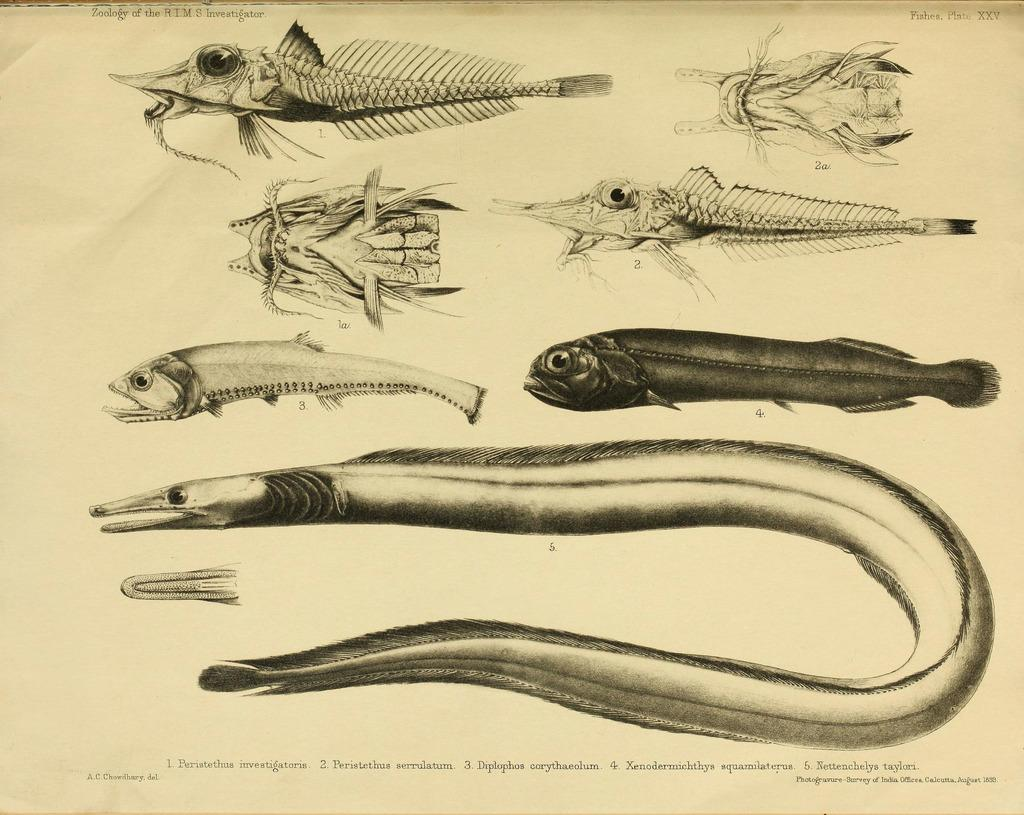What is present in the image? There is a paper in the image. What type of images are on the paper? The paper contains images of reptiles. Is there any text on the paper? Yes, there is text at the bottom of the paper. How many pigs are visible in the image? There are no pigs present in the image; it features a paper with images of reptiles. What type of frogs are depicted in the image? There are no frogs depicted in the image; it features a paper with images of reptiles. 